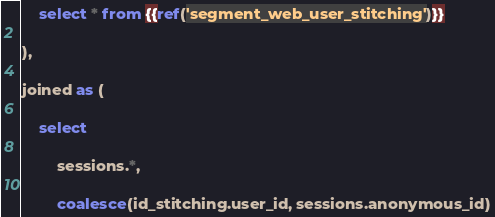Convert code to text. <code><loc_0><loc_0><loc_500><loc_500><_SQL_>
    select * from {{ref('segment_web_user_stitching')}}

),

joined as (

    select

        sessions.*,

        coalesce(id_stitching.user_id, sessions.anonymous_id)</code> 